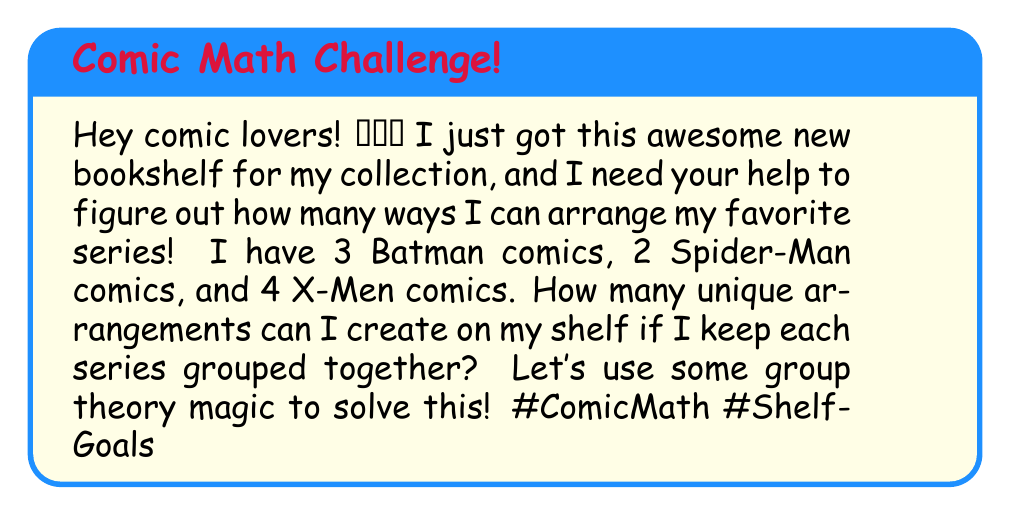Teach me how to tackle this problem. Let's break this down step-by-step using permutation groups:

1) First, we need to consider the comics as groups:
   - Batman group (3 comics)
   - Spider-Man group (2 comics)
   - X-Men group (4 comics)

2) We can think of arranging these groups as a permutation of 3 elements. This gives us $3! = 6$ possible arrangements of the groups.

3) Now, within each group, we need to consider the permutations:
   - Batman: $3! = 6$ permutations
   - Spider-Man: $2! = 2$ permutations
   - X-Men: $4! = 24$ permutations

4) By the Multiplication Principle, the total number of unique arrangements is:

   $$(3!) \cdot (3!) \cdot (2!) \cdot (4!)$$

5) Let's calculate:
   $$6 \cdot 6 \cdot 2 \cdot 24 = 1,728$$

This result can be interpreted using the Wreath product in group theory. We're essentially creating a permutation group that's a wreath product of the symmetric group $S_3$ (for the arrangement of the series) with the direct product of $S_3$, $S_2$, and $S_4$ (for the arrangements within each series).
Answer: There are 1,728 unique arrangements for the comic book shelf. 